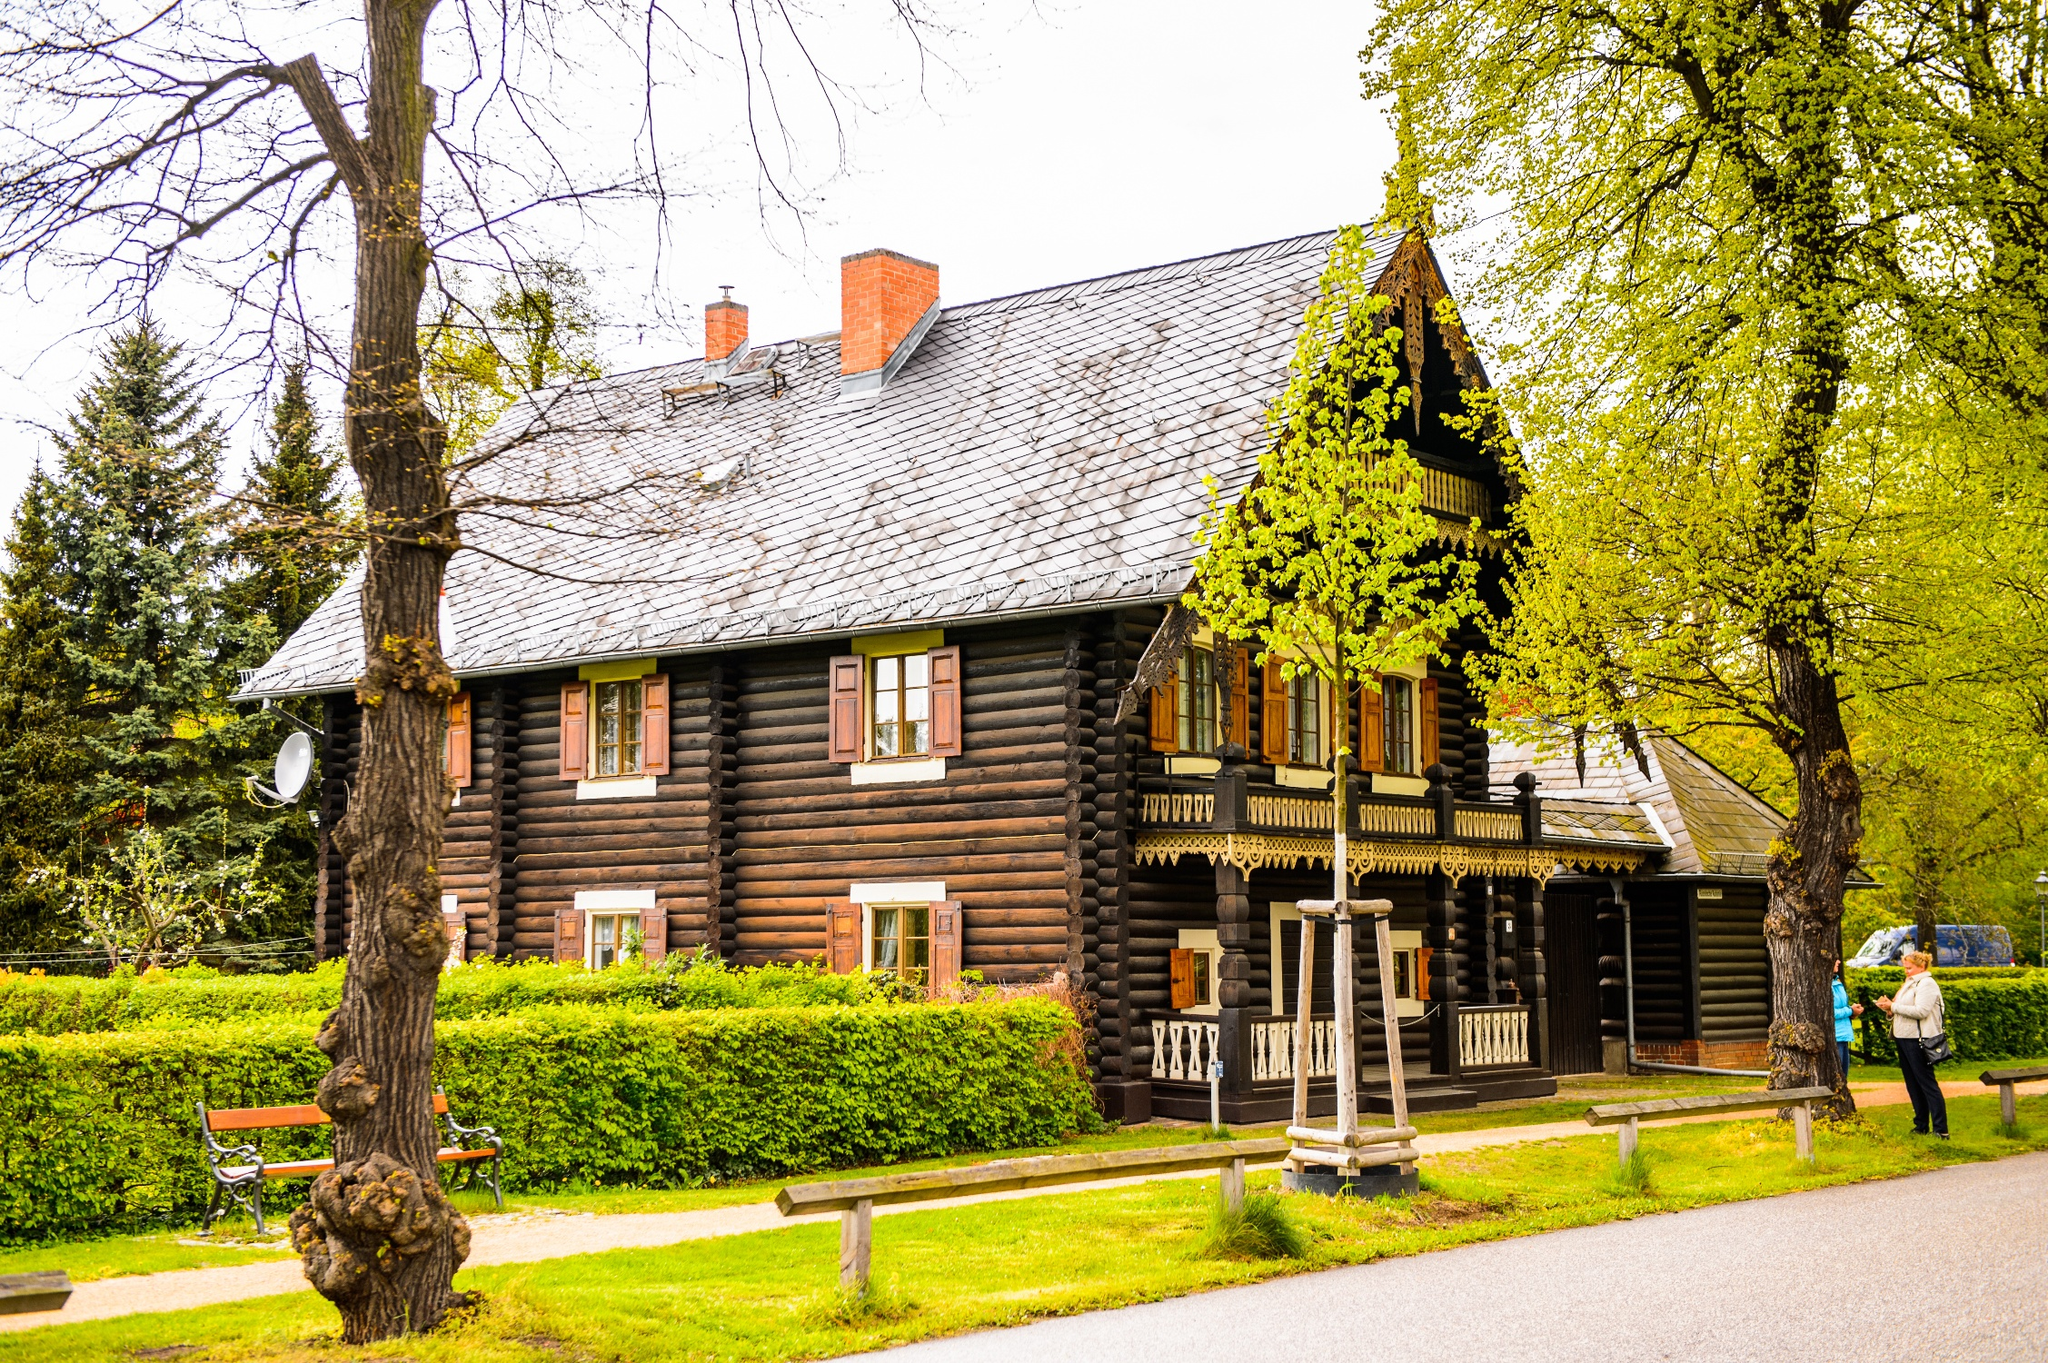Explain the visual content of the image in great detail.
 The image captures a quaint wooden house nestled amidst a serene park-like setting. The house, painted in a dark brown hue with contrasting white trim, boasts a steep roof and a charming porch. A white railing encircles the porch, adding to the house's rustic appeal. Two benches sit invitingly in front of the house, offering a place to rest and take in the tranquil surroundings. A path meanders through the lush greenery, leading the eye towards the house. The house also features a chimney, hinting at a cozy interior. The sky overhead is overcast, casting a soft, diffused light over the scene. The image exudes a sense of calm and tranquility, inviting one to step into this peaceful tableau. 